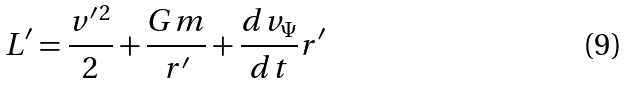Convert formula to latex. <formula><loc_0><loc_0><loc_500><loc_500>L ^ { \prime } = \frac { v ^ { \prime \, 2 } } { 2 } + \frac { G m } { r ^ { \prime } } + \frac { d v _ { \Psi } } { d t } r ^ { \prime }</formula> 